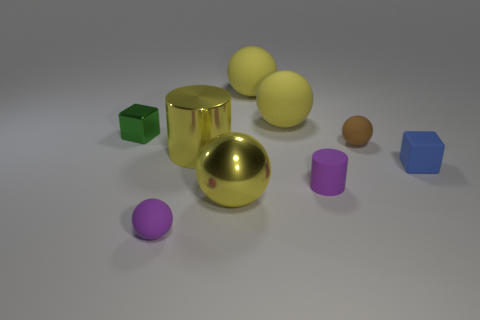Subtract all red blocks. How many yellow spheres are left? 3 Subtract all tiny purple rubber spheres. How many spheres are left? 4 Subtract all brown spheres. How many spheres are left? 4 Subtract all blue spheres. Subtract all green cubes. How many spheres are left? 5 Add 1 small yellow rubber cubes. How many objects exist? 10 Subtract all balls. How many objects are left? 4 Add 9 small cylinders. How many small cylinders exist? 10 Subtract 0 gray cylinders. How many objects are left? 9 Subtract all purple rubber objects. Subtract all big purple cylinders. How many objects are left? 7 Add 5 tiny blue matte blocks. How many tiny blue matte blocks are left? 6 